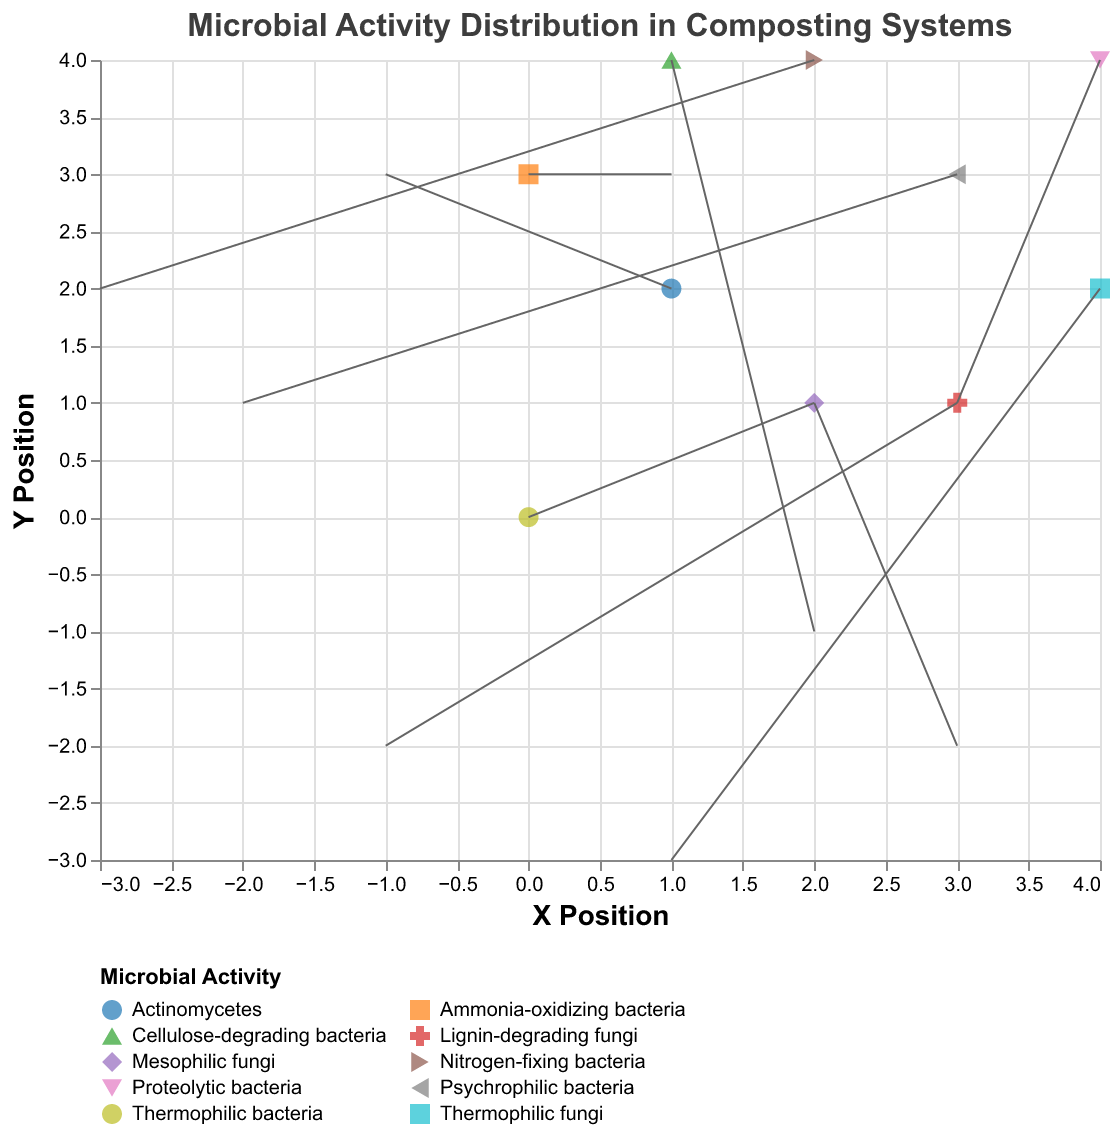How many types of microbial activities are represented in the plot? There are various colors and shapes in the legend, each representing a unique type of microbial activity. By counting these, you can determine the number of types.
Answer: 10 What's the direction of the vector for Thermophilic bacteria? Locate the point corresponding to Thermophilic bacteria. The vector direction is given by the arrows. For Thermophilic bacteria, the vector moves from the point (0,0) following the components (2,1).
Answer: (2,1) Which microbial activity has the longest vector overall? Examine the length of each vector in the plot. The length can be estimated visually by the length of the arrows. The microbial activity with the longest vector is the one pointing from (2,1) with vector (3,-2), which corresponds to Mesophilic fungi.
Answer: Mesophilic fungi Compare the vectors for Actinomycetes and Ammonia-oxidizing bacteria. Which one has a greater y-component? Find the y-components of both vectors. Actinomycetes has a y-component of 3 and Ammonia-oxidizing bacteria has a y-component of 3 as well. Thus, both have the same y-component.
Answer: Equal What is the color associated with Nitrogen-fixing bacteria? Observe the legend in the plot, which indicates the color for each microbial activity. The color associated with Nitrogen-fixing bacteria can be seen there.
Answer: Green Which vector is pointing in a primarily downward direction? Look for vectors with a negative y-component, indicating downward direction. For example, Thermophilic fungi has a vector (1,-3), pointing mainly downward.
Answer: Thermophilic fungi What is the x-position of Lignin-degrading fungi? Refer to the plotted points and locate the x-coordinate for Lignin-degrading fungi. The x-coordinate for this point is 3.
Answer: 3 Calculate the sum of the x-components of the vectors for Proteolytic bacteria and Cellulose-degrading bacteria. The x-component for Proteolytic bacteria is 3, and for Cellulose-degrading bacteria, it is 2. Summing these two values gives 3 + 2 = 5.
Answer: 5 Between Thermophilic bacteria and Mesophilic fungi, which has a larger x-component in its vector? Look at the x-components of both vectors: Thermophilic bacteria has an x-component of 2, while Mesophilic fungi has an x-component of 3. Thus, Mesophilic fungi has a larger x-component.
Answer: Mesophilic fungi Identify the microbial activity at position (4,2). Locate the point at (4,2) in the plot. The microbial activity at this position corresponds to the legend entry Thermophilic fungi.
Answer: Thermophilic fungi 